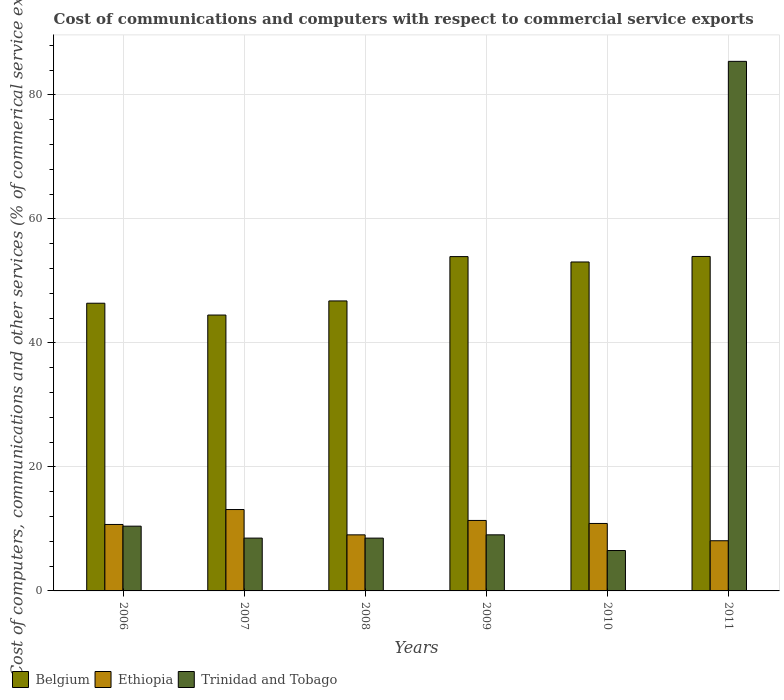How many different coloured bars are there?
Ensure brevity in your answer.  3. How many bars are there on the 2nd tick from the left?
Provide a succinct answer. 3. How many bars are there on the 6th tick from the right?
Make the answer very short. 3. What is the label of the 6th group of bars from the left?
Your answer should be compact. 2011. In how many cases, is the number of bars for a given year not equal to the number of legend labels?
Offer a terse response. 0. What is the cost of communications and computers in Trinidad and Tobago in 2006?
Offer a terse response. 10.44. Across all years, what is the maximum cost of communications and computers in Trinidad and Tobago?
Offer a very short reply. 85.4. Across all years, what is the minimum cost of communications and computers in Trinidad and Tobago?
Offer a terse response. 6.51. In which year was the cost of communications and computers in Trinidad and Tobago maximum?
Your answer should be compact. 2011. What is the total cost of communications and computers in Ethiopia in the graph?
Your answer should be compact. 63.22. What is the difference between the cost of communications and computers in Trinidad and Tobago in 2008 and that in 2010?
Your response must be concise. 2. What is the difference between the cost of communications and computers in Ethiopia in 2011 and the cost of communications and computers in Belgium in 2009?
Provide a succinct answer. -45.82. What is the average cost of communications and computers in Ethiopia per year?
Your answer should be very brief. 10.54. In the year 2011, what is the difference between the cost of communications and computers in Trinidad and Tobago and cost of communications and computers in Belgium?
Provide a succinct answer. 31.46. What is the ratio of the cost of communications and computers in Trinidad and Tobago in 2007 to that in 2010?
Provide a short and direct response. 1.31. Is the cost of communications and computers in Belgium in 2006 less than that in 2011?
Your answer should be compact. Yes. Is the difference between the cost of communications and computers in Trinidad and Tobago in 2007 and 2009 greater than the difference between the cost of communications and computers in Belgium in 2007 and 2009?
Offer a very short reply. Yes. What is the difference between the highest and the second highest cost of communications and computers in Belgium?
Your answer should be compact. 0.02. What is the difference between the highest and the lowest cost of communications and computers in Ethiopia?
Make the answer very short. 5.03. In how many years, is the cost of communications and computers in Ethiopia greater than the average cost of communications and computers in Ethiopia taken over all years?
Ensure brevity in your answer.  4. Is the sum of the cost of communications and computers in Belgium in 2008 and 2010 greater than the maximum cost of communications and computers in Ethiopia across all years?
Ensure brevity in your answer.  Yes. What does the 2nd bar from the left in 2009 represents?
Keep it short and to the point. Ethiopia. What does the 2nd bar from the right in 2010 represents?
Your response must be concise. Ethiopia. Is it the case that in every year, the sum of the cost of communications and computers in Trinidad and Tobago and cost of communications and computers in Ethiopia is greater than the cost of communications and computers in Belgium?
Make the answer very short. No. How many years are there in the graph?
Ensure brevity in your answer.  6. Are the values on the major ticks of Y-axis written in scientific E-notation?
Offer a very short reply. No. Does the graph contain any zero values?
Give a very brief answer. No. Where does the legend appear in the graph?
Your answer should be compact. Bottom left. How many legend labels are there?
Keep it short and to the point. 3. How are the legend labels stacked?
Offer a terse response. Horizontal. What is the title of the graph?
Your answer should be compact. Cost of communications and computers with respect to commercial service exports. Does "Latvia" appear as one of the legend labels in the graph?
Keep it short and to the point. No. What is the label or title of the X-axis?
Your response must be concise. Years. What is the label or title of the Y-axis?
Your answer should be compact. Cost of computers, communications and other services (% of commerical service exports). What is the Cost of computers, communications and other services (% of commerical service exports) of Belgium in 2006?
Provide a short and direct response. 46.39. What is the Cost of computers, communications and other services (% of commerical service exports) in Ethiopia in 2006?
Your response must be concise. 10.72. What is the Cost of computers, communications and other services (% of commerical service exports) in Trinidad and Tobago in 2006?
Provide a succinct answer. 10.44. What is the Cost of computers, communications and other services (% of commerical service exports) in Belgium in 2007?
Your response must be concise. 44.49. What is the Cost of computers, communications and other services (% of commerical service exports) in Ethiopia in 2007?
Keep it short and to the point. 13.12. What is the Cost of computers, communications and other services (% of commerical service exports) of Trinidad and Tobago in 2007?
Your response must be concise. 8.52. What is the Cost of computers, communications and other services (% of commerical service exports) in Belgium in 2008?
Your answer should be compact. 46.76. What is the Cost of computers, communications and other services (% of commerical service exports) of Ethiopia in 2008?
Provide a succinct answer. 9.04. What is the Cost of computers, communications and other services (% of commerical service exports) of Trinidad and Tobago in 2008?
Provide a short and direct response. 8.52. What is the Cost of computers, communications and other services (% of commerical service exports) in Belgium in 2009?
Your answer should be compact. 53.91. What is the Cost of computers, communications and other services (% of commerical service exports) in Ethiopia in 2009?
Ensure brevity in your answer.  11.37. What is the Cost of computers, communications and other services (% of commerical service exports) in Trinidad and Tobago in 2009?
Your answer should be compact. 9.05. What is the Cost of computers, communications and other services (% of commerical service exports) of Belgium in 2010?
Give a very brief answer. 53.05. What is the Cost of computers, communications and other services (% of commerical service exports) of Ethiopia in 2010?
Your answer should be compact. 10.88. What is the Cost of computers, communications and other services (% of commerical service exports) of Trinidad and Tobago in 2010?
Provide a succinct answer. 6.51. What is the Cost of computers, communications and other services (% of commerical service exports) in Belgium in 2011?
Provide a succinct answer. 53.93. What is the Cost of computers, communications and other services (% of commerical service exports) of Ethiopia in 2011?
Give a very brief answer. 8.09. What is the Cost of computers, communications and other services (% of commerical service exports) of Trinidad and Tobago in 2011?
Keep it short and to the point. 85.4. Across all years, what is the maximum Cost of computers, communications and other services (% of commerical service exports) in Belgium?
Your response must be concise. 53.93. Across all years, what is the maximum Cost of computers, communications and other services (% of commerical service exports) of Ethiopia?
Ensure brevity in your answer.  13.12. Across all years, what is the maximum Cost of computers, communications and other services (% of commerical service exports) of Trinidad and Tobago?
Offer a very short reply. 85.4. Across all years, what is the minimum Cost of computers, communications and other services (% of commerical service exports) of Belgium?
Make the answer very short. 44.49. Across all years, what is the minimum Cost of computers, communications and other services (% of commerical service exports) of Ethiopia?
Your answer should be compact. 8.09. Across all years, what is the minimum Cost of computers, communications and other services (% of commerical service exports) in Trinidad and Tobago?
Make the answer very short. 6.51. What is the total Cost of computers, communications and other services (% of commerical service exports) of Belgium in the graph?
Offer a terse response. 298.54. What is the total Cost of computers, communications and other services (% of commerical service exports) in Ethiopia in the graph?
Provide a short and direct response. 63.22. What is the total Cost of computers, communications and other services (% of commerical service exports) of Trinidad and Tobago in the graph?
Your answer should be compact. 128.43. What is the difference between the Cost of computers, communications and other services (% of commerical service exports) in Belgium in 2006 and that in 2007?
Provide a succinct answer. 1.9. What is the difference between the Cost of computers, communications and other services (% of commerical service exports) of Ethiopia in 2006 and that in 2007?
Your answer should be very brief. -2.41. What is the difference between the Cost of computers, communications and other services (% of commerical service exports) in Trinidad and Tobago in 2006 and that in 2007?
Offer a terse response. 1.93. What is the difference between the Cost of computers, communications and other services (% of commerical service exports) in Belgium in 2006 and that in 2008?
Offer a terse response. -0.37. What is the difference between the Cost of computers, communications and other services (% of commerical service exports) of Ethiopia in 2006 and that in 2008?
Your response must be concise. 1.68. What is the difference between the Cost of computers, communications and other services (% of commerical service exports) in Trinidad and Tobago in 2006 and that in 2008?
Keep it short and to the point. 1.93. What is the difference between the Cost of computers, communications and other services (% of commerical service exports) of Belgium in 2006 and that in 2009?
Keep it short and to the point. -7.52. What is the difference between the Cost of computers, communications and other services (% of commerical service exports) in Ethiopia in 2006 and that in 2009?
Provide a succinct answer. -0.65. What is the difference between the Cost of computers, communications and other services (% of commerical service exports) of Trinidad and Tobago in 2006 and that in 2009?
Provide a short and direct response. 1.4. What is the difference between the Cost of computers, communications and other services (% of commerical service exports) of Belgium in 2006 and that in 2010?
Your answer should be very brief. -6.65. What is the difference between the Cost of computers, communications and other services (% of commerical service exports) of Ethiopia in 2006 and that in 2010?
Provide a short and direct response. -0.16. What is the difference between the Cost of computers, communications and other services (% of commerical service exports) of Trinidad and Tobago in 2006 and that in 2010?
Your response must be concise. 3.93. What is the difference between the Cost of computers, communications and other services (% of commerical service exports) of Belgium in 2006 and that in 2011?
Provide a short and direct response. -7.54. What is the difference between the Cost of computers, communications and other services (% of commerical service exports) of Ethiopia in 2006 and that in 2011?
Make the answer very short. 2.62. What is the difference between the Cost of computers, communications and other services (% of commerical service exports) in Trinidad and Tobago in 2006 and that in 2011?
Give a very brief answer. -74.96. What is the difference between the Cost of computers, communications and other services (% of commerical service exports) in Belgium in 2007 and that in 2008?
Give a very brief answer. -2.28. What is the difference between the Cost of computers, communications and other services (% of commerical service exports) of Ethiopia in 2007 and that in 2008?
Give a very brief answer. 4.08. What is the difference between the Cost of computers, communications and other services (% of commerical service exports) of Trinidad and Tobago in 2007 and that in 2008?
Give a very brief answer. 0. What is the difference between the Cost of computers, communications and other services (% of commerical service exports) of Belgium in 2007 and that in 2009?
Ensure brevity in your answer.  -9.43. What is the difference between the Cost of computers, communications and other services (% of commerical service exports) in Ethiopia in 2007 and that in 2009?
Ensure brevity in your answer.  1.76. What is the difference between the Cost of computers, communications and other services (% of commerical service exports) in Trinidad and Tobago in 2007 and that in 2009?
Offer a terse response. -0.53. What is the difference between the Cost of computers, communications and other services (% of commerical service exports) of Belgium in 2007 and that in 2010?
Provide a short and direct response. -8.56. What is the difference between the Cost of computers, communications and other services (% of commerical service exports) of Ethiopia in 2007 and that in 2010?
Your answer should be compact. 2.24. What is the difference between the Cost of computers, communications and other services (% of commerical service exports) in Trinidad and Tobago in 2007 and that in 2010?
Your answer should be compact. 2. What is the difference between the Cost of computers, communications and other services (% of commerical service exports) of Belgium in 2007 and that in 2011?
Offer a terse response. -9.45. What is the difference between the Cost of computers, communications and other services (% of commerical service exports) of Ethiopia in 2007 and that in 2011?
Your answer should be very brief. 5.03. What is the difference between the Cost of computers, communications and other services (% of commerical service exports) in Trinidad and Tobago in 2007 and that in 2011?
Your response must be concise. -76.88. What is the difference between the Cost of computers, communications and other services (% of commerical service exports) in Belgium in 2008 and that in 2009?
Make the answer very short. -7.15. What is the difference between the Cost of computers, communications and other services (% of commerical service exports) in Ethiopia in 2008 and that in 2009?
Make the answer very short. -2.33. What is the difference between the Cost of computers, communications and other services (% of commerical service exports) in Trinidad and Tobago in 2008 and that in 2009?
Give a very brief answer. -0.53. What is the difference between the Cost of computers, communications and other services (% of commerical service exports) of Belgium in 2008 and that in 2010?
Your answer should be very brief. -6.28. What is the difference between the Cost of computers, communications and other services (% of commerical service exports) of Ethiopia in 2008 and that in 2010?
Make the answer very short. -1.84. What is the difference between the Cost of computers, communications and other services (% of commerical service exports) of Trinidad and Tobago in 2008 and that in 2010?
Your answer should be compact. 2. What is the difference between the Cost of computers, communications and other services (% of commerical service exports) of Belgium in 2008 and that in 2011?
Ensure brevity in your answer.  -7.17. What is the difference between the Cost of computers, communications and other services (% of commerical service exports) in Ethiopia in 2008 and that in 2011?
Offer a very short reply. 0.95. What is the difference between the Cost of computers, communications and other services (% of commerical service exports) of Trinidad and Tobago in 2008 and that in 2011?
Give a very brief answer. -76.88. What is the difference between the Cost of computers, communications and other services (% of commerical service exports) of Belgium in 2009 and that in 2010?
Provide a short and direct response. 0.87. What is the difference between the Cost of computers, communications and other services (% of commerical service exports) in Ethiopia in 2009 and that in 2010?
Ensure brevity in your answer.  0.49. What is the difference between the Cost of computers, communications and other services (% of commerical service exports) in Trinidad and Tobago in 2009 and that in 2010?
Ensure brevity in your answer.  2.53. What is the difference between the Cost of computers, communications and other services (% of commerical service exports) in Belgium in 2009 and that in 2011?
Your response must be concise. -0.02. What is the difference between the Cost of computers, communications and other services (% of commerical service exports) of Ethiopia in 2009 and that in 2011?
Your answer should be compact. 3.27. What is the difference between the Cost of computers, communications and other services (% of commerical service exports) in Trinidad and Tobago in 2009 and that in 2011?
Make the answer very short. -76.35. What is the difference between the Cost of computers, communications and other services (% of commerical service exports) in Belgium in 2010 and that in 2011?
Make the answer very short. -0.89. What is the difference between the Cost of computers, communications and other services (% of commerical service exports) of Ethiopia in 2010 and that in 2011?
Give a very brief answer. 2.79. What is the difference between the Cost of computers, communications and other services (% of commerical service exports) in Trinidad and Tobago in 2010 and that in 2011?
Provide a short and direct response. -78.88. What is the difference between the Cost of computers, communications and other services (% of commerical service exports) of Belgium in 2006 and the Cost of computers, communications and other services (% of commerical service exports) of Ethiopia in 2007?
Your answer should be compact. 33.27. What is the difference between the Cost of computers, communications and other services (% of commerical service exports) in Belgium in 2006 and the Cost of computers, communications and other services (% of commerical service exports) in Trinidad and Tobago in 2007?
Your answer should be very brief. 37.88. What is the difference between the Cost of computers, communications and other services (% of commerical service exports) in Ethiopia in 2006 and the Cost of computers, communications and other services (% of commerical service exports) in Trinidad and Tobago in 2007?
Offer a terse response. 2.2. What is the difference between the Cost of computers, communications and other services (% of commerical service exports) in Belgium in 2006 and the Cost of computers, communications and other services (% of commerical service exports) in Ethiopia in 2008?
Offer a terse response. 37.35. What is the difference between the Cost of computers, communications and other services (% of commerical service exports) in Belgium in 2006 and the Cost of computers, communications and other services (% of commerical service exports) in Trinidad and Tobago in 2008?
Keep it short and to the point. 37.88. What is the difference between the Cost of computers, communications and other services (% of commerical service exports) in Ethiopia in 2006 and the Cost of computers, communications and other services (% of commerical service exports) in Trinidad and Tobago in 2008?
Offer a very short reply. 2.2. What is the difference between the Cost of computers, communications and other services (% of commerical service exports) of Belgium in 2006 and the Cost of computers, communications and other services (% of commerical service exports) of Ethiopia in 2009?
Provide a short and direct response. 35.03. What is the difference between the Cost of computers, communications and other services (% of commerical service exports) of Belgium in 2006 and the Cost of computers, communications and other services (% of commerical service exports) of Trinidad and Tobago in 2009?
Ensure brevity in your answer.  37.35. What is the difference between the Cost of computers, communications and other services (% of commerical service exports) of Ethiopia in 2006 and the Cost of computers, communications and other services (% of commerical service exports) of Trinidad and Tobago in 2009?
Your answer should be very brief. 1.67. What is the difference between the Cost of computers, communications and other services (% of commerical service exports) of Belgium in 2006 and the Cost of computers, communications and other services (% of commerical service exports) of Ethiopia in 2010?
Keep it short and to the point. 35.51. What is the difference between the Cost of computers, communications and other services (% of commerical service exports) in Belgium in 2006 and the Cost of computers, communications and other services (% of commerical service exports) in Trinidad and Tobago in 2010?
Your answer should be very brief. 39.88. What is the difference between the Cost of computers, communications and other services (% of commerical service exports) of Ethiopia in 2006 and the Cost of computers, communications and other services (% of commerical service exports) of Trinidad and Tobago in 2010?
Offer a very short reply. 4.2. What is the difference between the Cost of computers, communications and other services (% of commerical service exports) in Belgium in 2006 and the Cost of computers, communications and other services (% of commerical service exports) in Ethiopia in 2011?
Offer a terse response. 38.3. What is the difference between the Cost of computers, communications and other services (% of commerical service exports) in Belgium in 2006 and the Cost of computers, communications and other services (% of commerical service exports) in Trinidad and Tobago in 2011?
Keep it short and to the point. -39.01. What is the difference between the Cost of computers, communications and other services (% of commerical service exports) of Ethiopia in 2006 and the Cost of computers, communications and other services (% of commerical service exports) of Trinidad and Tobago in 2011?
Keep it short and to the point. -74.68. What is the difference between the Cost of computers, communications and other services (% of commerical service exports) of Belgium in 2007 and the Cost of computers, communications and other services (% of commerical service exports) of Ethiopia in 2008?
Your answer should be very brief. 35.45. What is the difference between the Cost of computers, communications and other services (% of commerical service exports) in Belgium in 2007 and the Cost of computers, communications and other services (% of commerical service exports) in Trinidad and Tobago in 2008?
Provide a short and direct response. 35.97. What is the difference between the Cost of computers, communications and other services (% of commerical service exports) of Ethiopia in 2007 and the Cost of computers, communications and other services (% of commerical service exports) of Trinidad and Tobago in 2008?
Your answer should be compact. 4.61. What is the difference between the Cost of computers, communications and other services (% of commerical service exports) in Belgium in 2007 and the Cost of computers, communications and other services (% of commerical service exports) in Ethiopia in 2009?
Keep it short and to the point. 33.12. What is the difference between the Cost of computers, communications and other services (% of commerical service exports) of Belgium in 2007 and the Cost of computers, communications and other services (% of commerical service exports) of Trinidad and Tobago in 2009?
Your answer should be compact. 35.44. What is the difference between the Cost of computers, communications and other services (% of commerical service exports) in Ethiopia in 2007 and the Cost of computers, communications and other services (% of commerical service exports) in Trinidad and Tobago in 2009?
Ensure brevity in your answer.  4.08. What is the difference between the Cost of computers, communications and other services (% of commerical service exports) of Belgium in 2007 and the Cost of computers, communications and other services (% of commerical service exports) of Ethiopia in 2010?
Provide a succinct answer. 33.61. What is the difference between the Cost of computers, communications and other services (% of commerical service exports) of Belgium in 2007 and the Cost of computers, communications and other services (% of commerical service exports) of Trinidad and Tobago in 2010?
Keep it short and to the point. 37.97. What is the difference between the Cost of computers, communications and other services (% of commerical service exports) in Ethiopia in 2007 and the Cost of computers, communications and other services (% of commerical service exports) in Trinidad and Tobago in 2010?
Provide a succinct answer. 6.61. What is the difference between the Cost of computers, communications and other services (% of commerical service exports) in Belgium in 2007 and the Cost of computers, communications and other services (% of commerical service exports) in Ethiopia in 2011?
Offer a terse response. 36.4. What is the difference between the Cost of computers, communications and other services (% of commerical service exports) in Belgium in 2007 and the Cost of computers, communications and other services (% of commerical service exports) in Trinidad and Tobago in 2011?
Your answer should be very brief. -40.91. What is the difference between the Cost of computers, communications and other services (% of commerical service exports) in Ethiopia in 2007 and the Cost of computers, communications and other services (% of commerical service exports) in Trinidad and Tobago in 2011?
Your response must be concise. -72.27. What is the difference between the Cost of computers, communications and other services (% of commerical service exports) in Belgium in 2008 and the Cost of computers, communications and other services (% of commerical service exports) in Ethiopia in 2009?
Your answer should be compact. 35.4. What is the difference between the Cost of computers, communications and other services (% of commerical service exports) in Belgium in 2008 and the Cost of computers, communications and other services (% of commerical service exports) in Trinidad and Tobago in 2009?
Offer a terse response. 37.72. What is the difference between the Cost of computers, communications and other services (% of commerical service exports) of Ethiopia in 2008 and the Cost of computers, communications and other services (% of commerical service exports) of Trinidad and Tobago in 2009?
Ensure brevity in your answer.  -0. What is the difference between the Cost of computers, communications and other services (% of commerical service exports) in Belgium in 2008 and the Cost of computers, communications and other services (% of commerical service exports) in Ethiopia in 2010?
Offer a very short reply. 35.88. What is the difference between the Cost of computers, communications and other services (% of commerical service exports) in Belgium in 2008 and the Cost of computers, communications and other services (% of commerical service exports) in Trinidad and Tobago in 2010?
Keep it short and to the point. 40.25. What is the difference between the Cost of computers, communications and other services (% of commerical service exports) of Ethiopia in 2008 and the Cost of computers, communications and other services (% of commerical service exports) of Trinidad and Tobago in 2010?
Provide a short and direct response. 2.53. What is the difference between the Cost of computers, communications and other services (% of commerical service exports) in Belgium in 2008 and the Cost of computers, communications and other services (% of commerical service exports) in Ethiopia in 2011?
Make the answer very short. 38.67. What is the difference between the Cost of computers, communications and other services (% of commerical service exports) of Belgium in 2008 and the Cost of computers, communications and other services (% of commerical service exports) of Trinidad and Tobago in 2011?
Offer a terse response. -38.63. What is the difference between the Cost of computers, communications and other services (% of commerical service exports) in Ethiopia in 2008 and the Cost of computers, communications and other services (% of commerical service exports) in Trinidad and Tobago in 2011?
Offer a terse response. -76.36. What is the difference between the Cost of computers, communications and other services (% of commerical service exports) of Belgium in 2009 and the Cost of computers, communications and other services (% of commerical service exports) of Ethiopia in 2010?
Your response must be concise. 43.03. What is the difference between the Cost of computers, communications and other services (% of commerical service exports) of Belgium in 2009 and the Cost of computers, communications and other services (% of commerical service exports) of Trinidad and Tobago in 2010?
Keep it short and to the point. 47.4. What is the difference between the Cost of computers, communications and other services (% of commerical service exports) of Ethiopia in 2009 and the Cost of computers, communications and other services (% of commerical service exports) of Trinidad and Tobago in 2010?
Offer a terse response. 4.85. What is the difference between the Cost of computers, communications and other services (% of commerical service exports) of Belgium in 2009 and the Cost of computers, communications and other services (% of commerical service exports) of Ethiopia in 2011?
Offer a very short reply. 45.82. What is the difference between the Cost of computers, communications and other services (% of commerical service exports) of Belgium in 2009 and the Cost of computers, communications and other services (% of commerical service exports) of Trinidad and Tobago in 2011?
Provide a short and direct response. -31.48. What is the difference between the Cost of computers, communications and other services (% of commerical service exports) in Ethiopia in 2009 and the Cost of computers, communications and other services (% of commerical service exports) in Trinidad and Tobago in 2011?
Offer a terse response. -74.03. What is the difference between the Cost of computers, communications and other services (% of commerical service exports) of Belgium in 2010 and the Cost of computers, communications and other services (% of commerical service exports) of Ethiopia in 2011?
Keep it short and to the point. 44.95. What is the difference between the Cost of computers, communications and other services (% of commerical service exports) of Belgium in 2010 and the Cost of computers, communications and other services (% of commerical service exports) of Trinidad and Tobago in 2011?
Your answer should be very brief. -32.35. What is the difference between the Cost of computers, communications and other services (% of commerical service exports) in Ethiopia in 2010 and the Cost of computers, communications and other services (% of commerical service exports) in Trinidad and Tobago in 2011?
Provide a short and direct response. -74.52. What is the average Cost of computers, communications and other services (% of commerical service exports) of Belgium per year?
Your answer should be compact. 49.76. What is the average Cost of computers, communications and other services (% of commerical service exports) of Ethiopia per year?
Ensure brevity in your answer.  10.54. What is the average Cost of computers, communications and other services (% of commerical service exports) of Trinidad and Tobago per year?
Keep it short and to the point. 21.41. In the year 2006, what is the difference between the Cost of computers, communications and other services (% of commerical service exports) of Belgium and Cost of computers, communications and other services (% of commerical service exports) of Ethiopia?
Make the answer very short. 35.68. In the year 2006, what is the difference between the Cost of computers, communications and other services (% of commerical service exports) in Belgium and Cost of computers, communications and other services (% of commerical service exports) in Trinidad and Tobago?
Your answer should be compact. 35.95. In the year 2006, what is the difference between the Cost of computers, communications and other services (% of commerical service exports) of Ethiopia and Cost of computers, communications and other services (% of commerical service exports) of Trinidad and Tobago?
Keep it short and to the point. 0.27. In the year 2007, what is the difference between the Cost of computers, communications and other services (% of commerical service exports) of Belgium and Cost of computers, communications and other services (% of commerical service exports) of Ethiopia?
Provide a succinct answer. 31.36. In the year 2007, what is the difference between the Cost of computers, communications and other services (% of commerical service exports) of Belgium and Cost of computers, communications and other services (% of commerical service exports) of Trinidad and Tobago?
Offer a very short reply. 35.97. In the year 2007, what is the difference between the Cost of computers, communications and other services (% of commerical service exports) in Ethiopia and Cost of computers, communications and other services (% of commerical service exports) in Trinidad and Tobago?
Provide a succinct answer. 4.61. In the year 2008, what is the difference between the Cost of computers, communications and other services (% of commerical service exports) of Belgium and Cost of computers, communications and other services (% of commerical service exports) of Ethiopia?
Ensure brevity in your answer.  37.72. In the year 2008, what is the difference between the Cost of computers, communications and other services (% of commerical service exports) of Belgium and Cost of computers, communications and other services (% of commerical service exports) of Trinidad and Tobago?
Ensure brevity in your answer.  38.25. In the year 2008, what is the difference between the Cost of computers, communications and other services (% of commerical service exports) in Ethiopia and Cost of computers, communications and other services (% of commerical service exports) in Trinidad and Tobago?
Provide a short and direct response. 0.53. In the year 2009, what is the difference between the Cost of computers, communications and other services (% of commerical service exports) in Belgium and Cost of computers, communications and other services (% of commerical service exports) in Ethiopia?
Your answer should be very brief. 42.55. In the year 2009, what is the difference between the Cost of computers, communications and other services (% of commerical service exports) in Belgium and Cost of computers, communications and other services (% of commerical service exports) in Trinidad and Tobago?
Provide a succinct answer. 44.87. In the year 2009, what is the difference between the Cost of computers, communications and other services (% of commerical service exports) in Ethiopia and Cost of computers, communications and other services (% of commerical service exports) in Trinidad and Tobago?
Offer a very short reply. 2.32. In the year 2010, what is the difference between the Cost of computers, communications and other services (% of commerical service exports) of Belgium and Cost of computers, communications and other services (% of commerical service exports) of Ethiopia?
Offer a terse response. 42.17. In the year 2010, what is the difference between the Cost of computers, communications and other services (% of commerical service exports) of Belgium and Cost of computers, communications and other services (% of commerical service exports) of Trinidad and Tobago?
Provide a short and direct response. 46.53. In the year 2010, what is the difference between the Cost of computers, communications and other services (% of commerical service exports) in Ethiopia and Cost of computers, communications and other services (% of commerical service exports) in Trinidad and Tobago?
Provide a short and direct response. 4.36. In the year 2011, what is the difference between the Cost of computers, communications and other services (% of commerical service exports) of Belgium and Cost of computers, communications and other services (% of commerical service exports) of Ethiopia?
Make the answer very short. 45.84. In the year 2011, what is the difference between the Cost of computers, communications and other services (% of commerical service exports) of Belgium and Cost of computers, communications and other services (% of commerical service exports) of Trinidad and Tobago?
Ensure brevity in your answer.  -31.46. In the year 2011, what is the difference between the Cost of computers, communications and other services (% of commerical service exports) of Ethiopia and Cost of computers, communications and other services (% of commerical service exports) of Trinidad and Tobago?
Provide a short and direct response. -77.31. What is the ratio of the Cost of computers, communications and other services (% of commerical service exports) of Belgium in 2006 to that in 2007?
Offer a terse response. 1.04. What is the ratio of the Cost of computers, communications and other services (% of commerical service exports) of Ethiopia in 2006 to that in 2007?
Ensure brevity in your answer.  0.82. What is the ratio of the Cost of computers, communications and other services (% of commerical service exports) in Trinidad and Tobago in 2006 to that in 2007?
Ensure brevity in your answer.  1.23. What is the ratio of the Cost of computers, communications and other services (% of commerical service exports) of Belgium in 2006 to that in 2008?
Your response must be concise. 0.99. What is the ratio of the Cost of computers, communications and other services (% of commerical service exports) in Ethiopia in 2006 to that in 2008?
Make the answer very short. 1.19. What is the ratio of the Cost of computers, communications and other services (% of commerical service exports) in Trinidad and Tobago in 2006 to that in 2008?
Make the answer very short. 1.23. What is the ratio of the Cost of computers, communications and other services (% of commerical service exports) in Belgium in 2006 to that in 2009?
Keep it short and to the point. 0.86. What is the ratio of the Cost of computers, communications and other services (% of commerical service exports) in Ethiopia in 2006 to that in 2009?
Provide a short and direct response. 0.94. What is the ratio of the Cost of computers, communications and other services (% of commerical service exports) in Trinidad and Tobago in 2006 to that in 2009?
Make the answer very short. 1.15. What is the ratio of the Cost of computers, communications and other services (% of commerical service exports) in Belgium in 2006 to that in 2010?
Offer a terse response. 0.87. What is the ratio of the Cost of computers, communications and other services (% of commerical service exports) of Trinidad and Tobago in 2006 to that in 2010?
Your answer should be compact. 1.6. What is the ratio of the Cost of computers, communications and other services (% of commerical service exports) of Belgium in 2006 to that in 2011?
Offer a terse response. 0.86. What is the ratio of the Cost of computers, communications and other services (% of commerical service exports) in Ethiopia in 2006 to that in 2011?
Offer a very short reply. 1.32. What is the ratio of the Cost of computers, communications and other services (% of commerical service exports) of Trinidad and Tobago in 2006 to that in 2011?
Keep it short and to the point. 0.12. What is the ratio of the Cost of computers, communications and other services (% of commerical service exports) of Belgium in 2007 to that in 2008?
Your answer should be very brief. 0.95. What is the ratio of the Cost of computers, communications and other services (% of commerical service exports) in Ethiopia in 2007 to that in 2008?
Make the answer very short. 1.45. What is the ratio of the Cost of computers, communications and other services (% of commerical service exports) in Trinidad and Tobago in 2007 to that in 2008?
Provide a succinct answer. 1. What is the ratio of the Cost of computers, communications and other services (% of commerical service exports) of Belgium in 2007 to that in 2009?
Your answer should be compact. 0.83. What is the ratio of the Cost of computers, communications and other services (% of commerical service exports) of Ethiopia in 2007 to that in 2009?
Make the answer very short. 1.15. What is the ratio of the Cost of computers, communications and other services (% of commerical service exports) of Trinidad and Tobago in 2007 to that in 2009?
Offer a terse response. 0.94. What is the ratio of the Cost of computers, communications and other services (% of commerical service exports) in Belgium in 2007 to that in 2010?
Provide a short and direct response. 0.84. What is the ratio of the Cost of computers, communications and other services (% of commerical service exports) in Ethiopia in 2007 to that in 2010?
Keep it short and to the point. 1.21. What is the ratio of the Cost of computers, communications and other services (% of commerical service exports) in Trinidad and Tobago in 2007 to that in 2010?
Ensure brevity in your answer.  1.31. What is the ratio of the Cost of computers, communications and other services (% of commerical service exports) in Belgium in 2007 to that in 2011?
Make the answer very short. 0.82. What is the ratio of the Cost of computers, communications and other services (% of commerical service exports) in Ethiopia in 2007 to that in 2011?
Your answer should be compact. 1.62. What is the ratio of the Cost of computers, communications and other services (% of commerical service exports) of Trinidad and Tobago in 2007 to that in 2011?
Give a very brief answer. 0.1. What is the ratio of the Cost of computers, communications and other services (% of commerical service exports) in Belgium in 2008 to that in 2009?
Ensure brevity in your answer.  0.87. What is the ratio of the Cost of computers, communications and other services (% of commerical service exports) of Ethiopia in 2008 to that in 2009?
Make the answer very short. 0.8. What is the ratio of the Cost of computers, communications and other services (% of commerical service exports) of Trinidad and Tobago in 2008 to that in 2009?
Your response must be concise. 0.94. What is the ratio of the Cost of computers, communications and other services (% of commerical service exports) in Belgium in 2008 to that in 2010?
Ensure brevity in your answer.  0.88. What is the ratio of the Cost of computers, communications and other services (% of commerical service exports) in Ethiopia in 2008 to that in 2010?
Provide a succinct answer. 0.83. What is the ratio of the Cost of computers, communications and other services (% of commerical service exports) of Trinidad and Tobago in 2008 to that in 2010?
Make the answer very short. 1.31. What is the ratio of the Cost of computers, communications and other services (% of commerical service exports) in Belgium in 2008 to that in 2011?
Your answer should be very brief. 0.87. What is the ratio of the Cost of computers, communications and other services (% of commerical service exports) in Ethiopia in 2008 to that in 2011?
Provide a short and direct response. 1.12. What is the ratio of the Cost of computers, communications and other services (% of commerical service exports) in Trinidad and Tobago in 2008 to that in 2011?
Your answer should be compact. 0.1. What is the ratio of the Cost of computers, communications and other services (% of commerical service exports) of Belgium in 2009 to that in 2010?
Keep it short and to the point. 1.02. What is the ratio of the Cost of computers, communications and other services (% of commerical service exports) in Ethiopia in 2009 to that in 2010?
Your answer should be compact. 1.04. What is the ratio of the Cost of computers, communications and other services (% of commerical service exports) in Trinidad and Tobago in 2009 to that in 2010?
Your response must be concise. 1.39. What is the ratio of the Cost of computers, communications and other services (% of commerical service exports) in Belgium in 2009 to that in 2011?
Offer a very short reply. 1. What is the ratio of the Cost of computers, communications and other services (% of commerical service exports) in Ethiopia in 2009 to that in 2011?
Provide a short and direct response. 1.4. What is the ratio of the Cost of computers, communications and other services (% of commerical service exports) in Trinidad and Tobago in 2009 to that in 2011?
Make the answer very short. 0.11. What is the ratio of the Cost of computers, communications and other services (% of commerical service exports) in Belgium in 2010 to that in 2011?
Give a very brief answer. 0.98. What is the ratio of the Cost of computers, communications and other services (% of commerical service exports) in Ethiopia in 2010 to that in 2011?
Your answer should be very brief. 1.34. What is the ratio of the Cost of computers, communications and other services (% of commerical service exports) of Trinidad and Tobago in 2010 to that in 2011?
Provide a short and direct response. 0.08. What is the difference between the highest and the second highest Cost of computers, communications and other services (% of commerical service exports) of Belgium?
Ensure brevity in your answer.  0.02. What is the difference between the highest and the second highest Cost of computers, communications and other services (% of commerical service exports) of Ethiopia?
Offer a very short reply. 1.76. What is the difference between the highest and the second highest Cost of computers, communications and other services (% of commerical service exports) of Trinidad and Tobago?
Your response must be concise. 74.96. What is the difference between the highest and the lowest Cost of computers, communications and other services (% of commerical service exports) in Belgium?
Your answer should be very brief. 9.45. What is the difference between the highest and the lowest Cost of computers, communications and other services (% of commerical service exports) of Ethiopia?
Make the answer very short. 5.03. What is the difference between the highest and the lowest Cost of computers, communications and other services (% of commerical service exports) in Trinidad and Tobago?
Your answer should be compact. 78.88. 